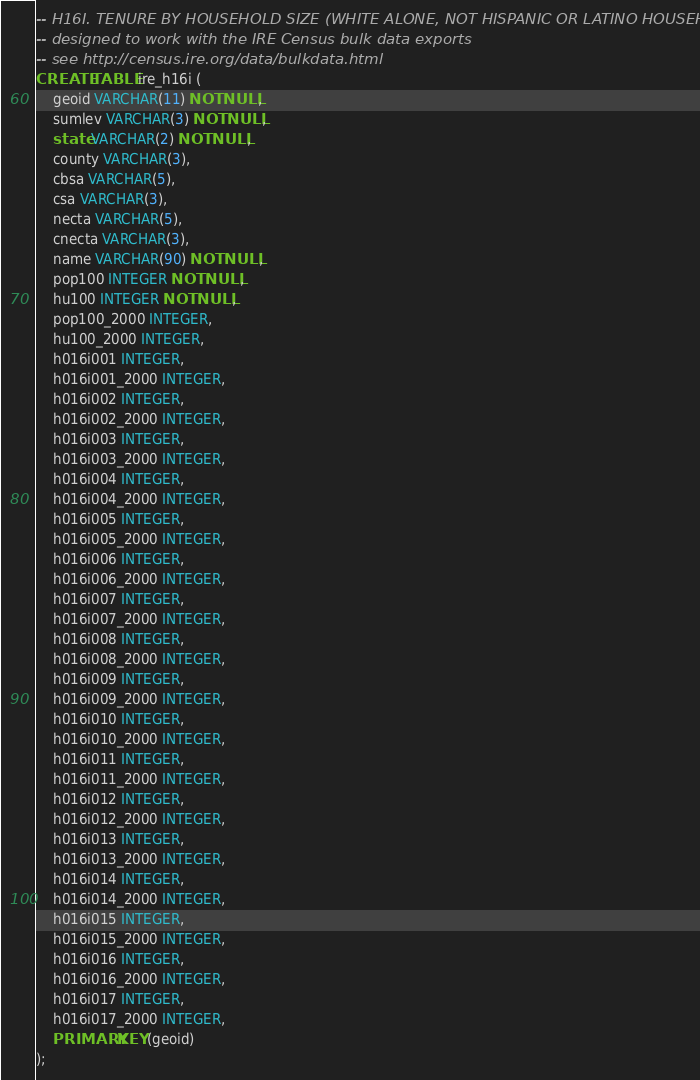<code> <loc_0><loc_0><loc_500><loc_500><_SQL_>-- H16I. TENURE BY HOUSEHOLD SIZE (WHITE ALONE, NOT HISPANIC OR LATINO HOUSEHOLDER)
-- designed to work with the IRE Census bulk data exports
-- see http://census.ire.org/data/bulkdata.html
CREATE TABLE ire_h16i (
	geoid VARCHAR(11) NOT NULL, 
	sumlev VARCHAR(3) NOT NULL, 
	state VARCHAR(2) NOT NULL, 
	county VARCHAR(3), 
	cbsa VARCHAR(5), 
	csa VARCHAR(3), 
	necta VARCHAR(5), 
	cnecta VARCHAR(3), 
	name VARCHAR(90) NOT NULL, 
	pop100 INTEGER NOT NULL, 
	hu100 INTEGER NOT NULL, 
	pop100_2000 INTEGER, 
	hu100_2000 INTEGER, 
	h016i001 INTEGER, 
	h016i001_2000 INTEGER, 
	h016i002 INTEGER, 
	h016i002_2000 INTEGER, 
	h016i003 INTEGER, 
	h016i003_2000 INTEGER, 
	h016i004 INTEGER, 
	h016i004_2000 INTEGER, 
	h016i005 INTEGER, 
	h016i005_2000 INTEGER, 
	h016i006 INTEGER, 
	h016i006_2000 INTEGER, 
	h016i007 INTEGER, 
	h016i007_2000 INTEGER, 
	h016i008 INTEGER, 
	h016i008_2000 INTEGER, 
	h016i009 INTEGER, 
	h016i009_2000 INTEGER, 
	h016i010 INTEGER, 
	h016i010_2000 INTEGER, 
	h016i011 INTEGER, 
	h016i011_2000 INTEGER, 
	h016i012 INTEGER, 
	h016i012_2000 INTEGER, 
	h016i013 INTEGER, 
	h016i013_2000 INTEGER, 
	h016i014 INTEGER, 
	h016i014_2000 INTEGER, 
	h016i015 INTEGER, 
	h016i015_2000 INTEGER, 
	h016i016 INTEGER, 
	h016i016_2000 INTEGER, 
	h016i017 INTEGER, 
	h016i017_2000 INTEGER, 
	PRIMARY KEY (geoid)
);
</code> 